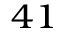<formula> <loc_0><loc_0><loc_500><loc_500>^ { 4 1 }</formula> 